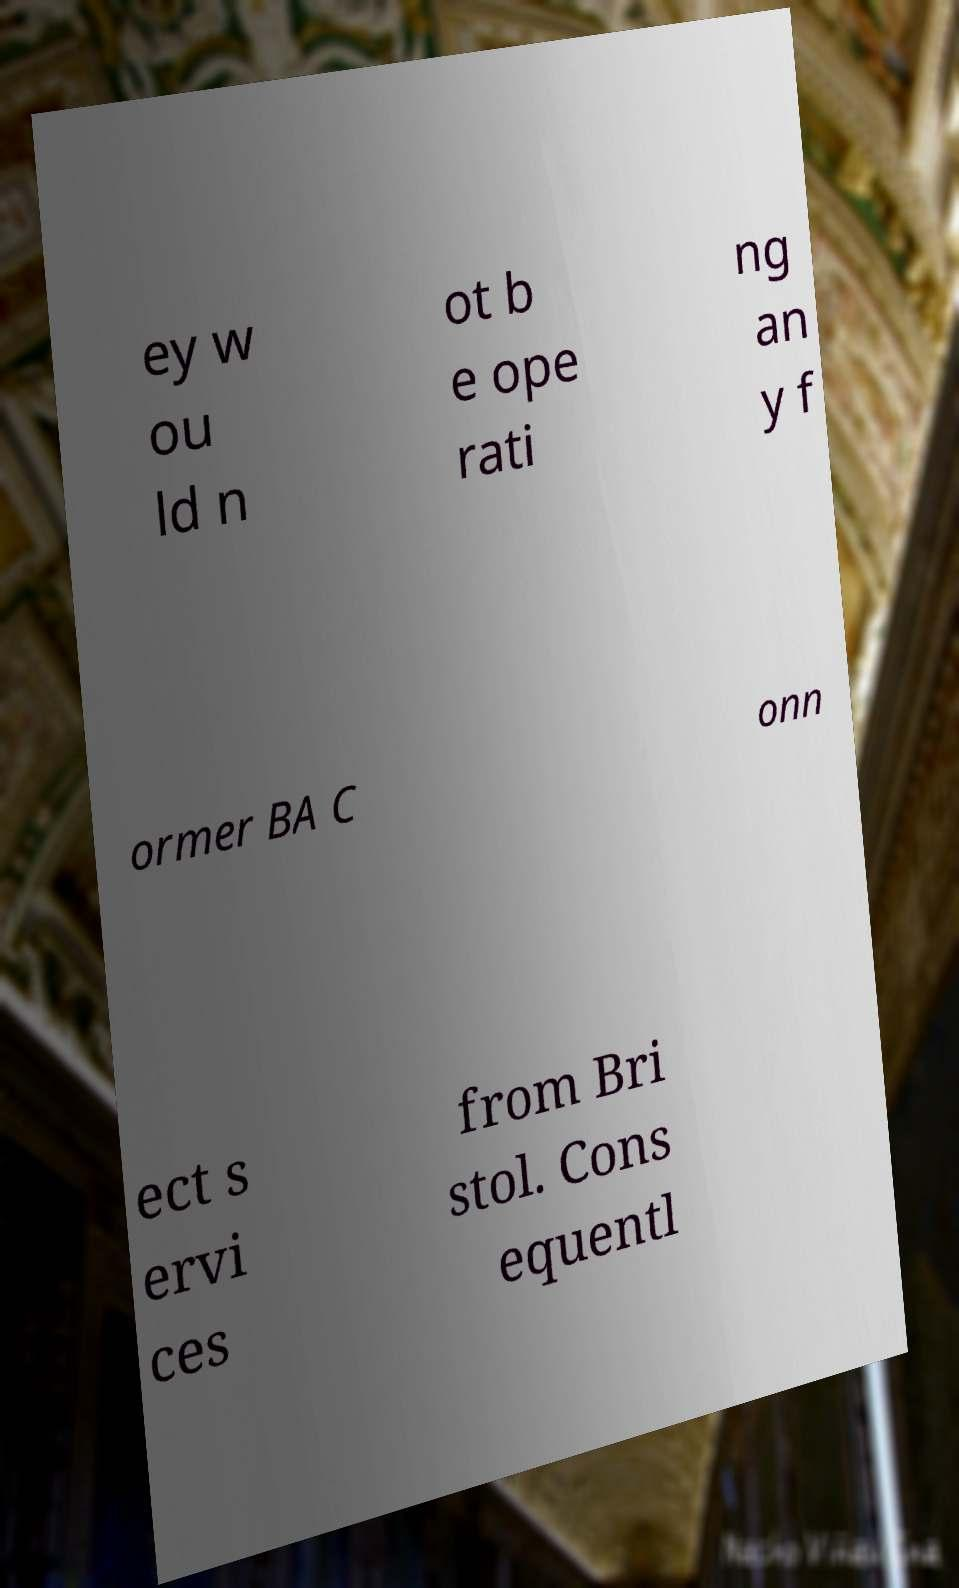For documentation purposes, I need the text within this image transcribed. Could you provide that? ey w ou ld n ot b e ope rati ng an y f ormer BA C onn ect s ervi ces from Bri stol. Cons equentl 